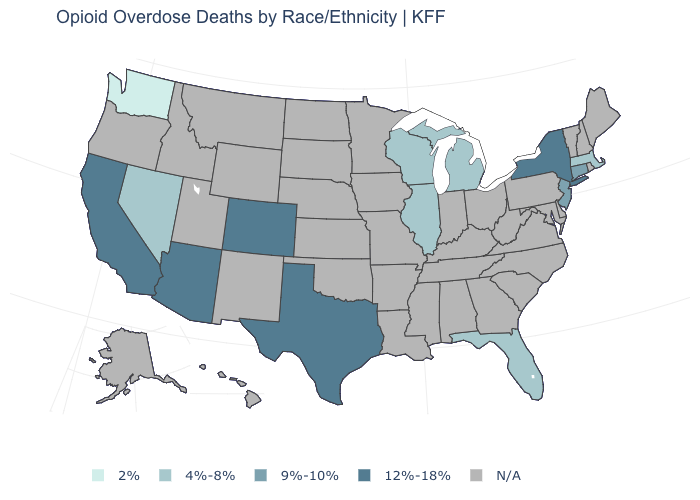Among the states that border Utah , does Arizona have the highest value?
Short answer required. Yes. What is the value of Arizona?
Short answer required. 12%-18%. What is the value of Ohio?
Concise answer only. N/A. What is the value of Alaska?
Keep it brief. N/A. What is the value of North Dakota?
Be succinct. N/A. Name the states that have a value in the range 12%-18%?
Quick response, please. Arizona, California, Colorado, New York, Texas. Which states hav the highest value in the MidWest?
Short answer required. Illinois, Michigan, Wisconsin. What is the highest value in the MidWest ?
Keep it brief. 4%-8%. What is the value of North Carolina?
Write a very short answer. N/A. What is the highest value in states that border New Mexico?
Short answer required. 12%-18%. What is the value of Oregon?
Keep it brief. N/A. What is the lowest value in the MidWest?
Answer briefly. 4%-8%. Does Washington have the lowest value in the USA?
Quick response, please. Yes. 